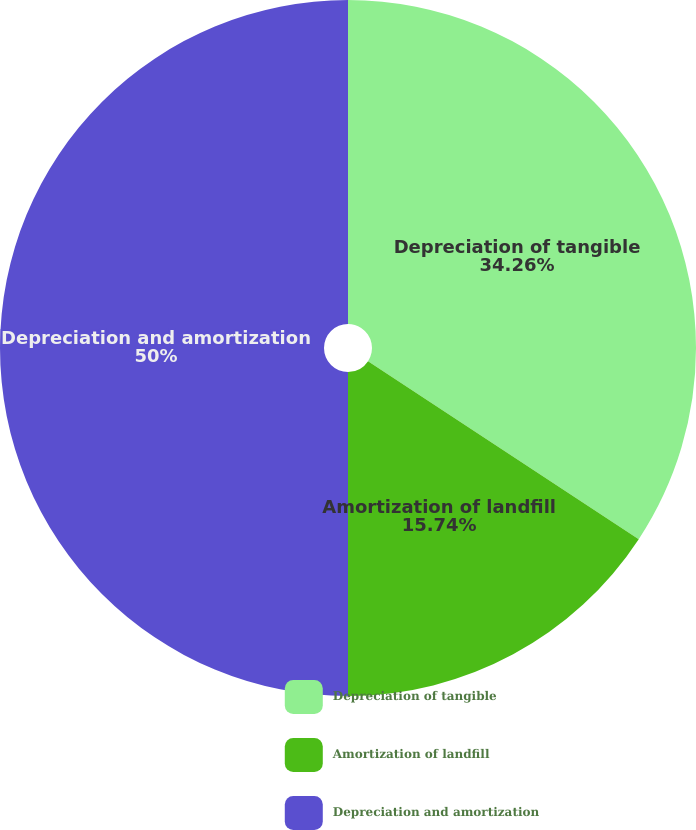Convert chart to OTSL. <chart><loc_0><loc_0><loc_500><loc_500><pie_chart><fcel>Depreciation of tangible<fcel>Amortization of landfill<fcel>Depreciation and amortization<nl><fcel>34.26%<fcel>15.74%<fcel>50.0%<nl></chart> 